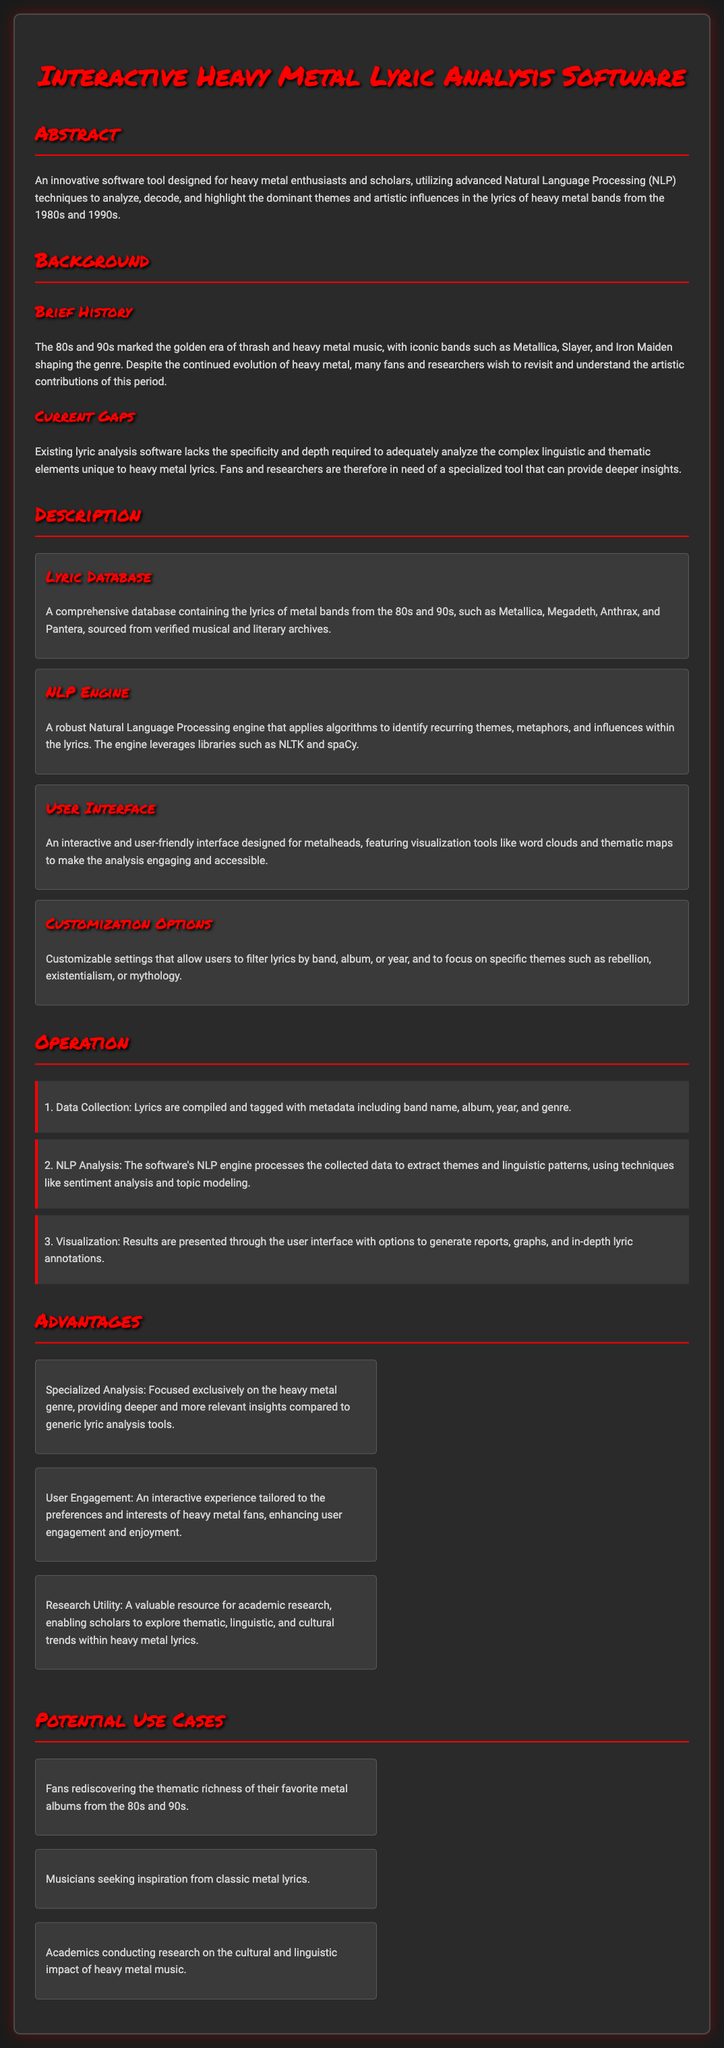What is the title of the software? The title of the software is listed prominently at the beginning of the document.
Answer: Interactive Heavy Metal Lyric Analysis Software Which decade does the software focus on? The software specifically analyzes lyrics from heavy metal bands in the specified decades.
Answer: 1980s and 1990s Name one band mentioned in the lyric database. The document lists several iconic bands in the database section, one of which can be acknowledged.
Answer: Metallica What is one key technique used in the NLP engine? The document describes certain algorithms and techniques applied in the NLP engine.
Answer: Sentiment analysis What is one customization option available to users? The software offers settings that allow users to filter lyrics based on specific criteria mentioned in the customization section.
Answer: Filter by band How many steps are outlined in the operation section? The operation section details a specific number of method steps that are used in the software.
Answer: Three What major gap does this software aim to fill? The background section highlights the need for a particular type of analysis tool.
Answer: Specialized tool for heavy metal lyrics What is one potential use case for this software? Potential use cases for the software are illustrated in the document, showcasing various audiences and contexts.
Answer: Academics conducting research Who is the target audience for this software? The abstract and background indicate the specific group of individuals targeted by the tool.
Answer: Heavy metal enthusiasts and scholars 